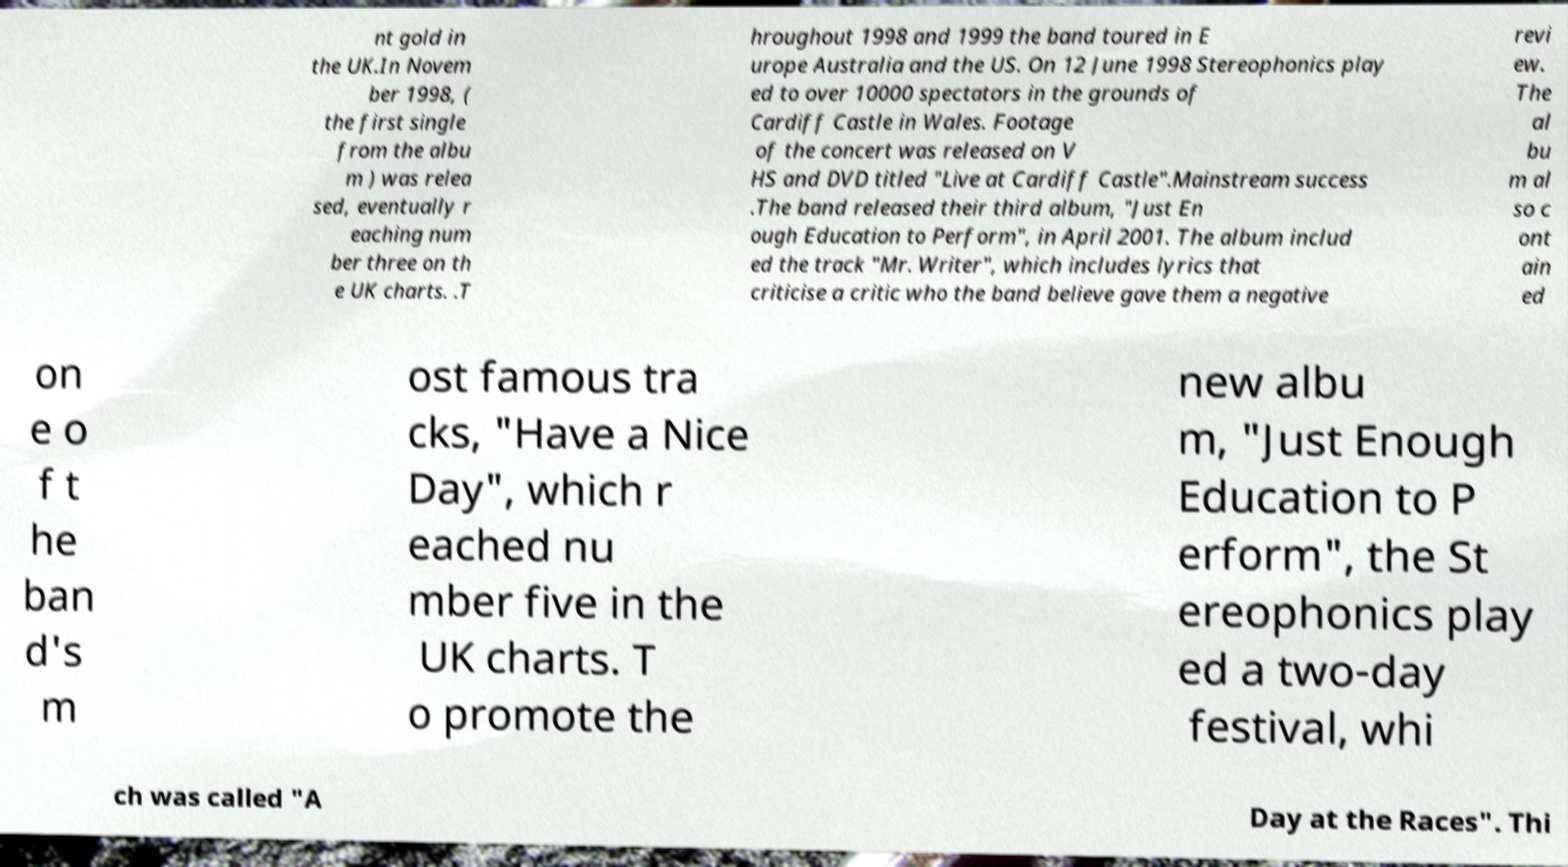Can you read and provide the text displayed in the image?This photo seems to have some interesting text. Can you extract and type it out for me? nt gold in the UK.In Novem ber 1998, ( the first single from the albu m ) was relea sed, eventually r eaching num ber three on th e UK charts. .T hroughout 1998 and 1999 the band toured in E urope Australia and the US. On 12 June 1998 Stereophonics play ed to over 10000 spectators in the grounds of Cardiff Castle in Wales. Footage of the concert was released on V HS and DVD titled "Live at Cardiff Castle".Mainstream success .The band released their third album, "Just En ough Education to Perform", in April 2001. The album includ ed the track "Mr. Writer", which includes lyrics that criticise a critic who the band believe gave them a negative revi ew. The al bu m al so c ont ain ed on e o f t he ban d's m ost famous tra cks, "Have a Nice Day", which r eached nu mber five in the UK charts. T o promote the new albu m, "Just Enough Education to P erform", the St ereophonics play ed a two-day festival, whi ch was called "A Day at the Races". Thi 